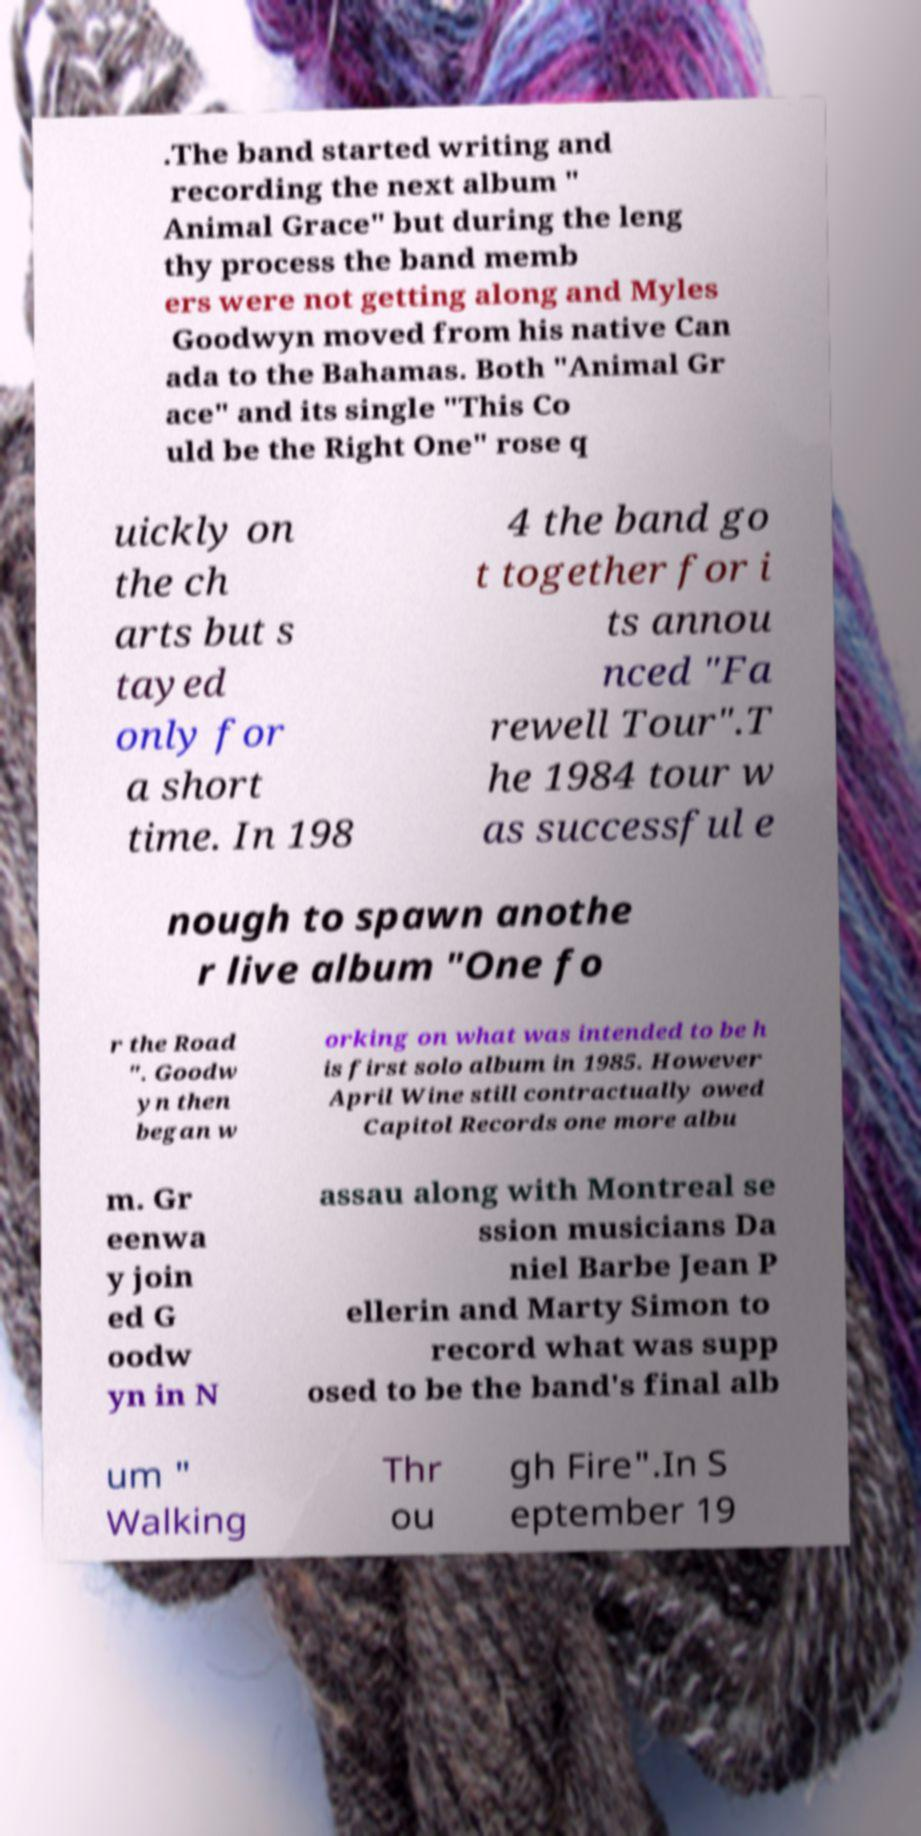Please read and relay the text visible in this image. What does it say? .The band started writing and recording the next album " Animal Grace" but during the leng thy process the band memb ers were not getting along and Myles Goodwyn moved from his native Can ada to the Bahamas. Both "Animal Gr ace" and its single "This Co uld be the Right One" rose q uickly on the ch arts but s tayed only for a short time. In 198 4 the band go t together for i ts annou nced "Fa rewell Tour".T he 1984 tour w as successful e nough to spawn anothe r live album "One fo r the Road ". Goodw yn then began w orking on what was intended to be h is first solo album in 1985. However April Wine still contractually owed Capitol Records one more albu m. Gr eenwa y join ed G oodw yn in N assau along with Montreal se ssion musicians Da niel Barbe Jean P ellerin and Marty Simon to record what was supp osed to be the band's final alb um " Walking Thr ou gh Fire".In S eptember 19 